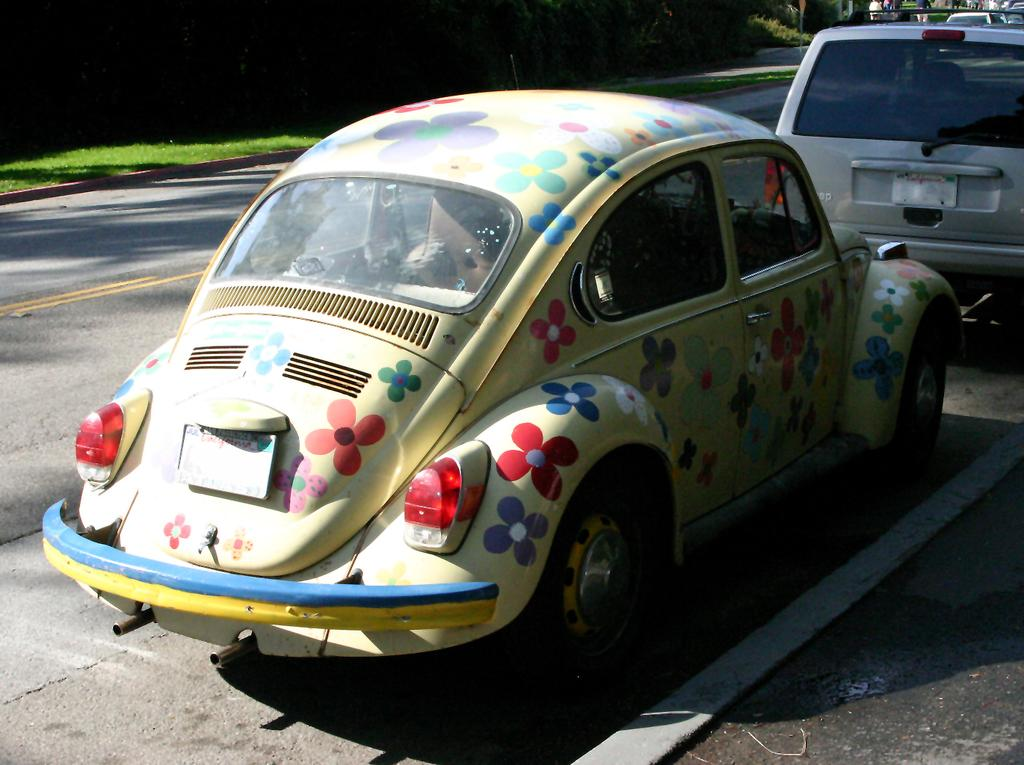What type of vehicles can be seen on the road in the image? There are cars on the road in the image. What type of path is present for pedestrians in the image? There is a sidewalk in the image. Who or what is present in the image besides the cars and sidewalk? There are persons in the image. What type of vegetation can be seen in the image? There are trees and grass in the image. What language is being spoken by the persons in the image? The provided facts do not mention any specific language being spoken by the persons in the image. Where can one find a shop in the image? There is no shop present in the image. --- Facts: 1. There is a person holding a book in the image. 2. The person is sitting on a chair. 3. There is a table in the image. 4. The table has a lamp on it. 5. There is a window in the image. Absurd Topics: ocean, parrot, bicycle Conversation: What is the person in the image holding? The person in the image is holding a book. What is the person sitting on in the image? The person is sitting on a chair. What object can be seen on the table in the image? The table has a lamp on it. What feature is present in the background of the image? There is a window in the image. Reasoning: Let's think step by step in order to produce the conversation. We start by identifying the main subject in the image, which is the person holding a book. Then, we expand the conversation to include other items that are also visible, such as the chair, table, lamp, and window. Each question is designed to elicit a specific detail about the image that is known from the provided facts. Absurd Question/Answer: Can you see the ocean in the image? No, there is no ocean present in the image. What type of bird is sitting on the person's shoulder in the image? There is no bird present in the image. 